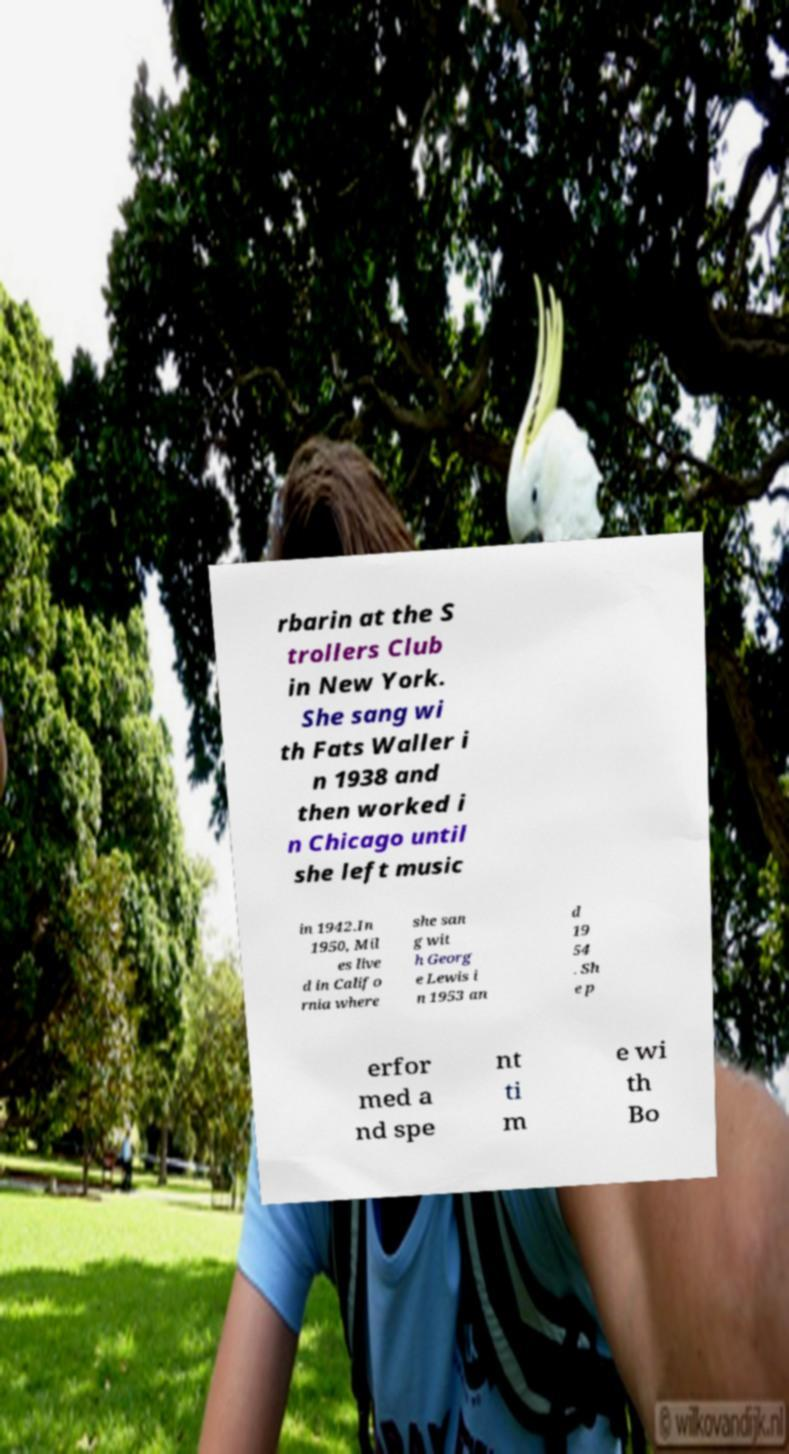For documentation purposes, I need the text within this image transcribed. Could you provide that? rbarin at the S trollers Club in New York. She sang wi th Fats Waller i n 1938 and then worked i n Chicago until she left music in 1942.In 1950, Mil es live d in Califo rnia where she san g wit h Georg e Lewis i n 1953 an d 19 54 . Sh e p erfor med a nd spe nt ti m e wi th Bo 